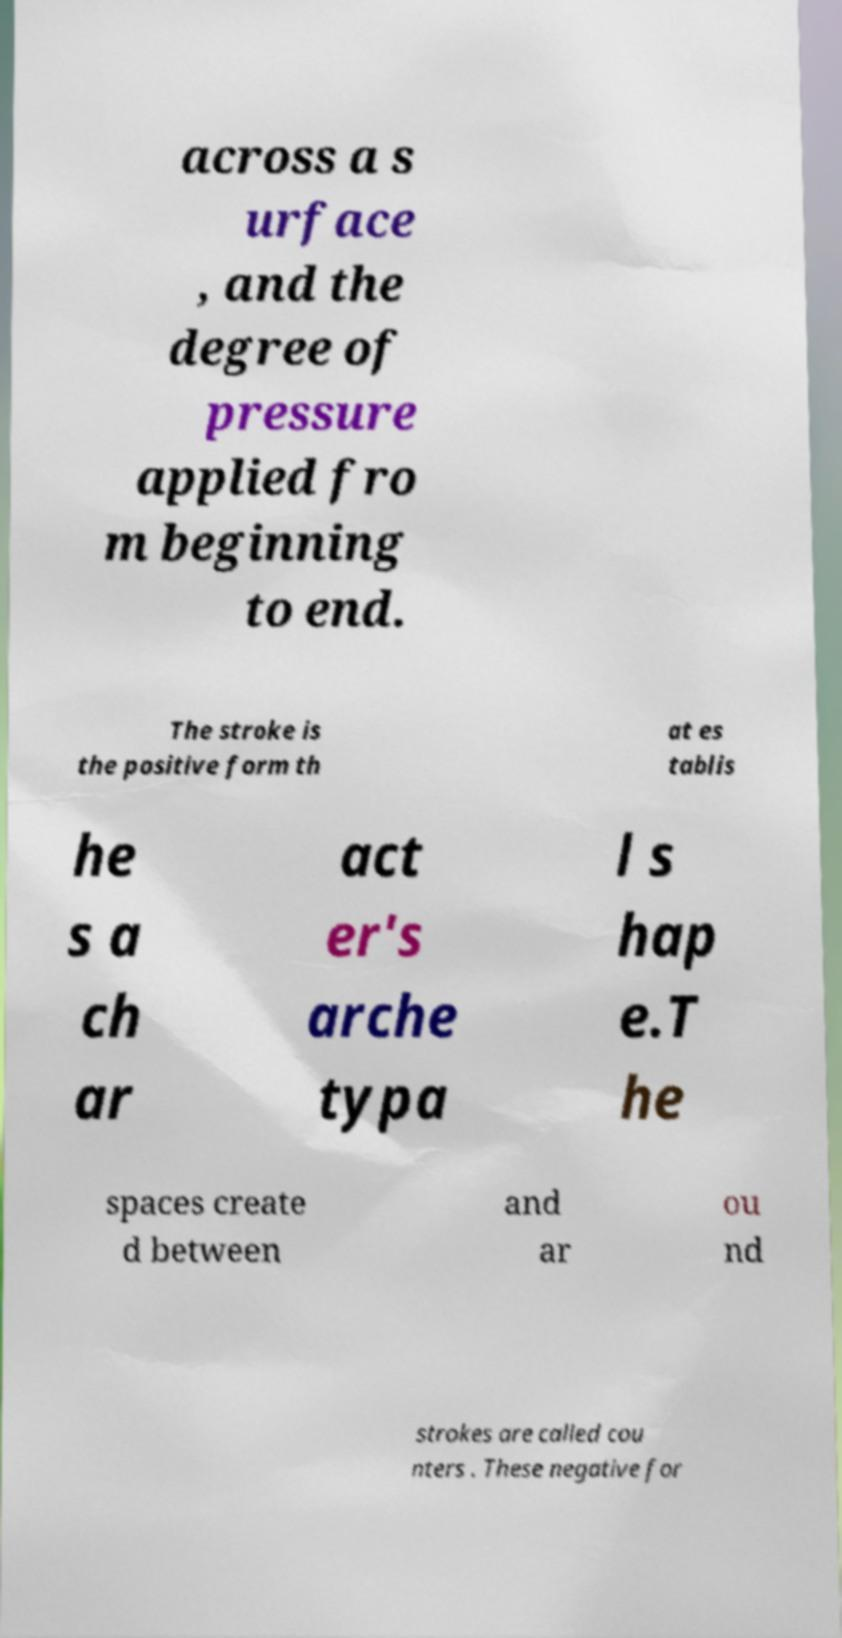Could you assist in decoding the text presented in this image and type it out clearly? across a s urface , and the degree of pressure applied fro m beginning to end. The stroke is the positive form th at es tablis he s a ch ar act er's arche typa l s hap e.T he spaces create d between and ar ou nd strokes are called cou nters . These negative for 